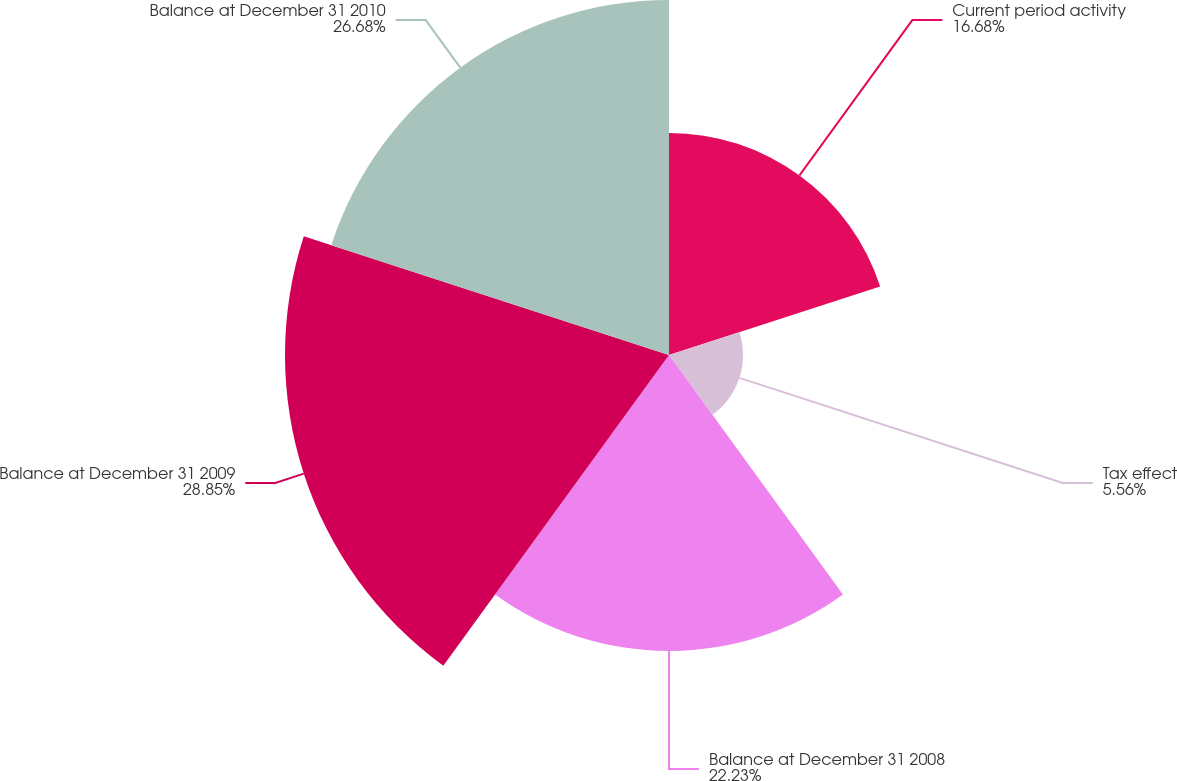<chart> <loc_0><loc_0><loc_500><loc_500><pie_chart><fcel>Current period activity<fcel>Tax effect<fcel>Balance at December 31 2008<fcel>Balance at December 31 2009<fcel>Balance at December 31 2010<nl><fcel>16.68%<fcel>5.56%<fcel>22.23%<fcel>28.85%<fcel>26.68%<nl></chart> 